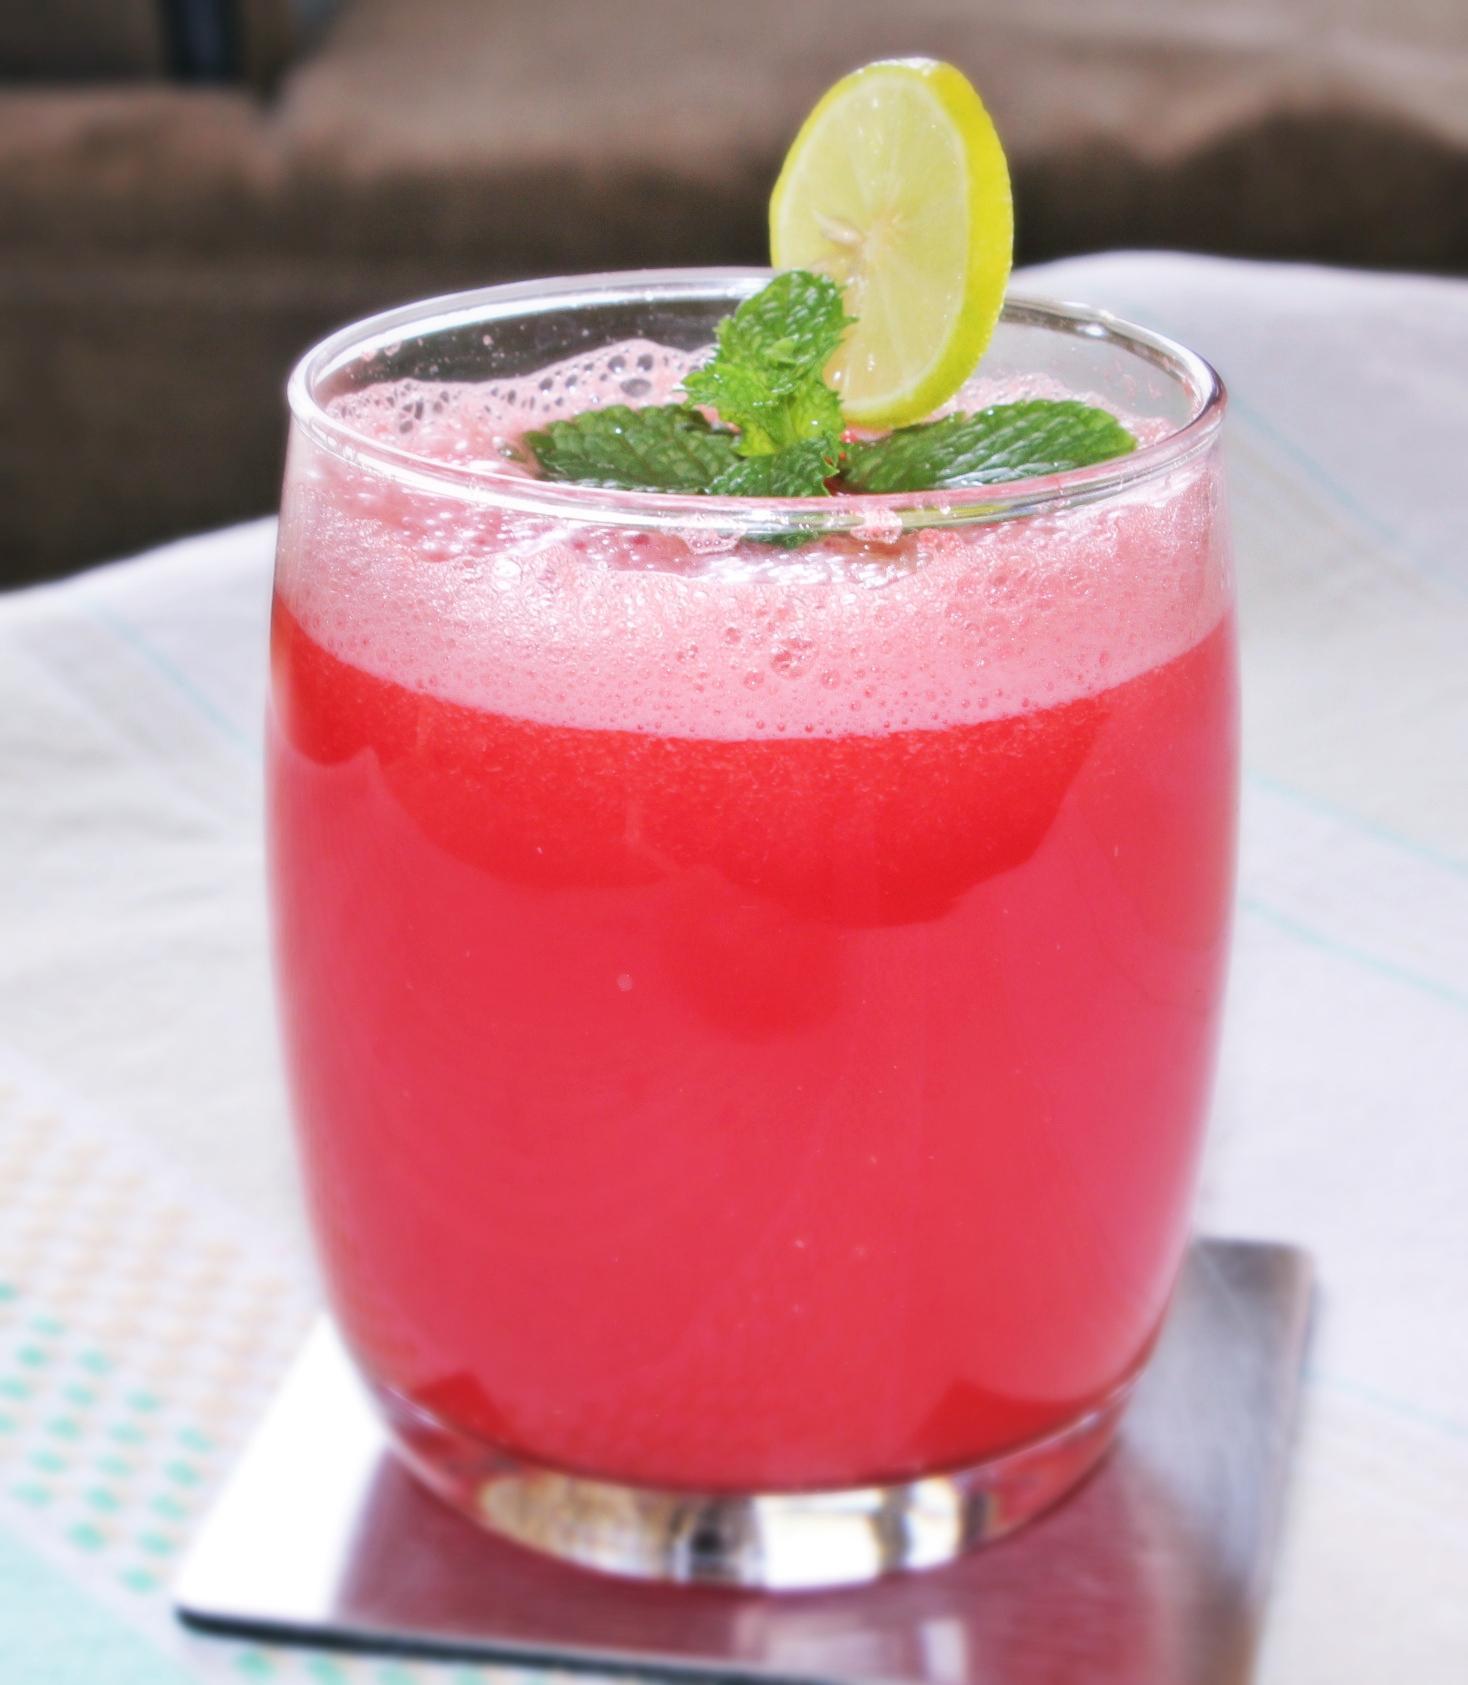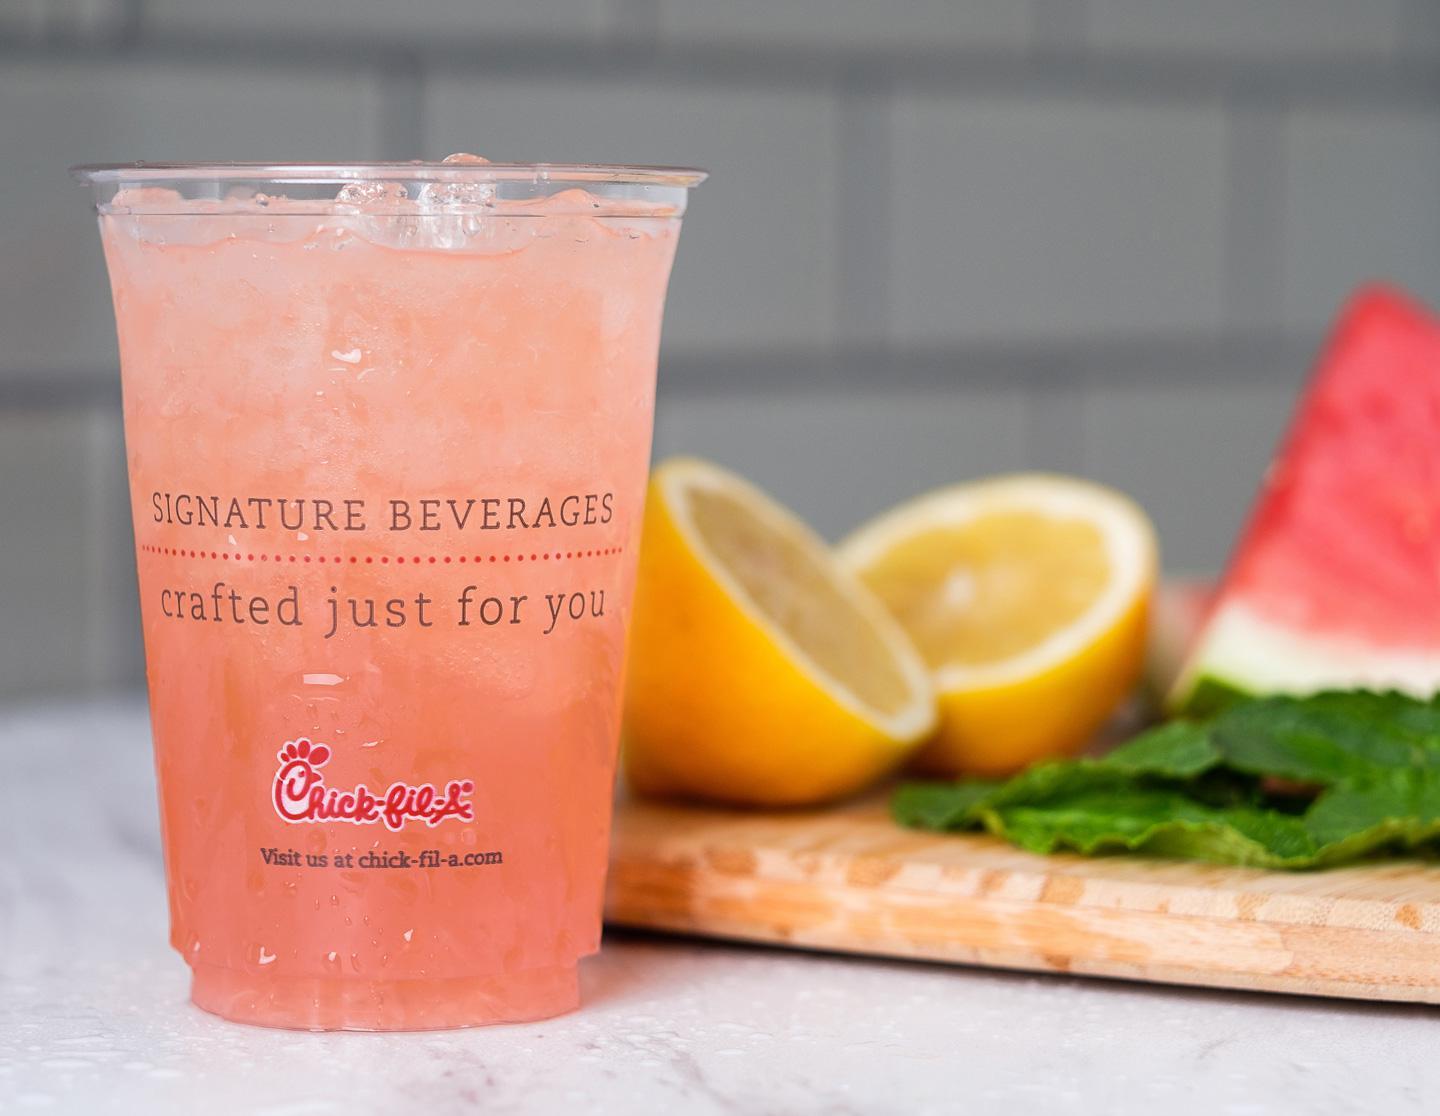The first image is the image on the left, the second image is the image on the right. For the images displayed, is the sentence "Exactly one prepared beverage glass is shown in each image." factually correct? Answer yes or no. Yes. The first image is the image on the left, the second image is the image on the right. For the images shown, is this caption "An image shows exactly one drink garnished with a yellow citrus slice and green leaves." true? Answer yes or no. Yes. 